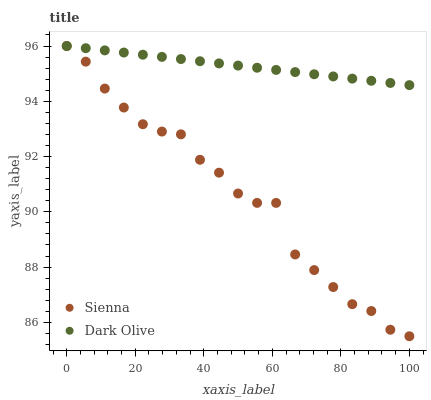Does Sienna have the minimum area under the curve?
Answer yes or no. Yes. Does Dark Olive have the maximum area under the curve?
Answer yes or no. Yes. Does Dark Olive have the minimum area under the curve?
Answer yes or no. No. Is Dark Olive the smoothest?
Answer yes or no. Yes. Is Sienna the roughest?
Answer yes or no. Yes. Is Dark Olive the roughest?
Answer yes or no. No. Does Sienna have the lowest value?
Answer yes or no. Yes. Does Dark Olive have the lowest value?
Answer yes or no. No. Does Dark Olive have the highest value?
Answer yes or no. Yes. Does Sienna intersect Dark Olive?
Answer yes or no. Yes. Is Sienna less than Dark Olive?
Answer yes or no. No. Is Sienna greater than Dark Olive?
Answer yes or no. No. 